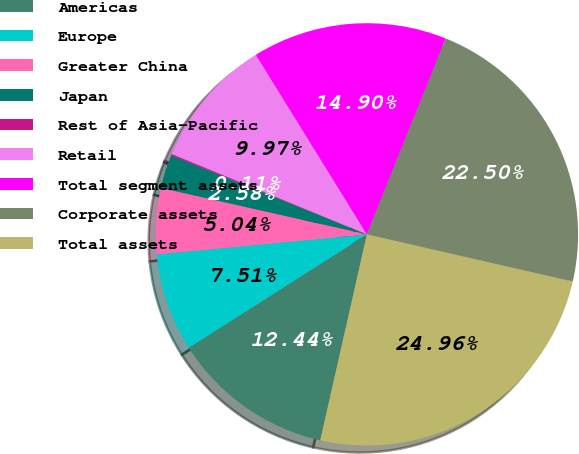Convert chart. <chart><loc_0><loc_0><loc_500><loc_500><pie_chart><fcel>Americas<fcel>Europe<fcel>Greater China<fcel>Japan<fcel>Rest of Asia-Pacific<fcel>Retail<fcel>Total segment assets<fcel>Corporate assets<fcel>Total assets<nl><fcel>12.44%<fcel>7.51%<fcel>5.04%<fcel>2.58%<fcel>0.11%<fcel>9.97%<fcel>14.9%<fcel>22.5%<fcel>24.96%<nl></chart> 